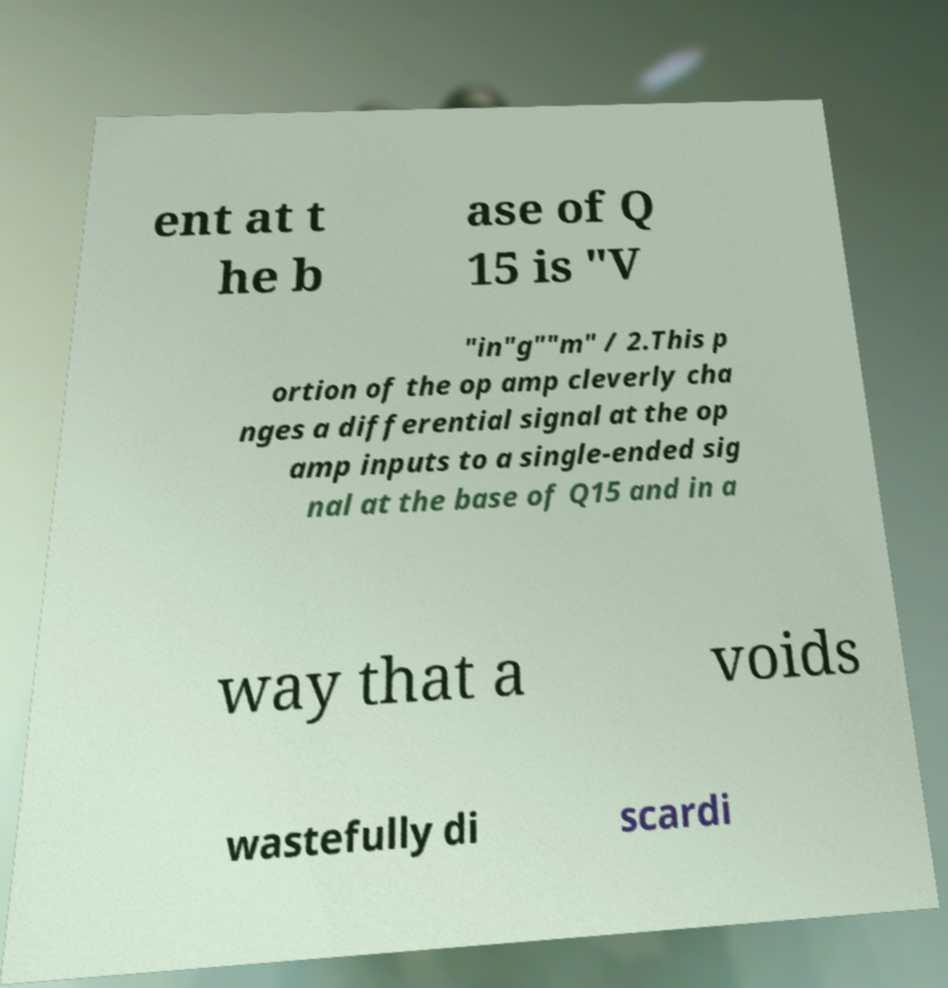Please identify and transcribe the text found in this image. ent at t he b ase of Q 15 is "V "in"g""m" / 2.This p ortion of the op amp cleverly cha nges a differential signal at the op amp inputs to a single-ended sig nal at the base of Q15 and in a way that a voids wastefully di scardi 